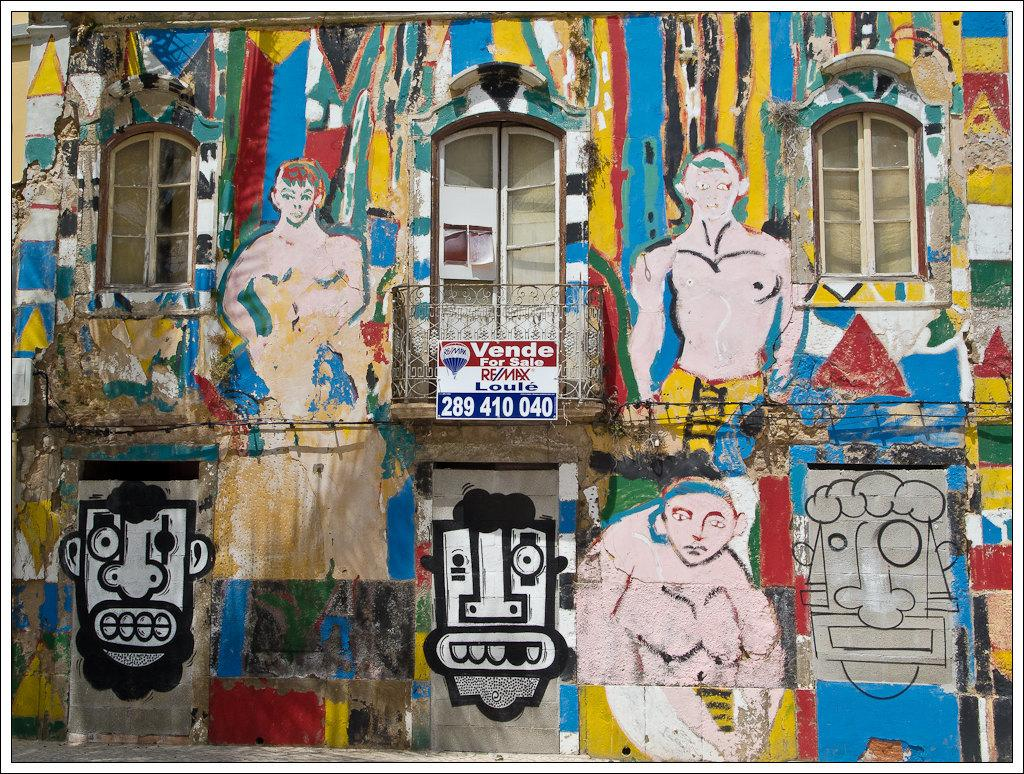What architectural feature can be seen in the image? There are windows in the image. What is hanging on the wall in the image? There is a wall with a painting in the image. What type of decorative item is present in the image? There is a poster in the image. How many family members can be seen visiting the property in the image? There is no reference to family members or a visitor in the image, so it is not possible to answer that question. 